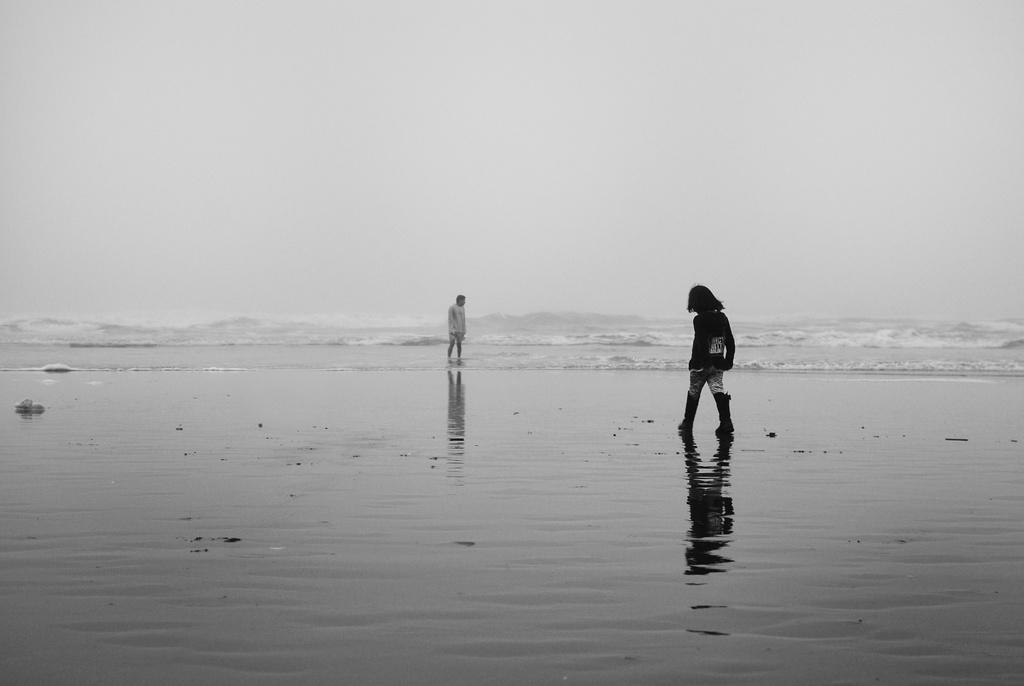How many people are in the image? There are two persons standing in the image. What is the color scheme of the image? The image is black and white in color. What can be seen in the background of the image? There is water visible in the background of the image. What type of bit is the man holding in the image? There is no man or bit present in the image; it features two persons standing in a black and white setting with water visible in the background. 